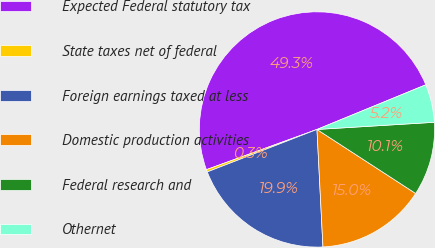Convert chart to OTSL. <chart><loc_0><loc_0><loc_500><loc_500><pie_chart><fcel>Expected Federal statutory tax<fcel>State taxes net of federal<fcel>Foreign earnings taxed at less<fcel>Domestic production activities<fcel>Federal research and<fcel>Othernet<nl><fcel>49.35%<fcel>0.33%<fcel>19.93%<fcel>15.03%<fcel>10.13%<fcel>5.23%<nl></chart> 